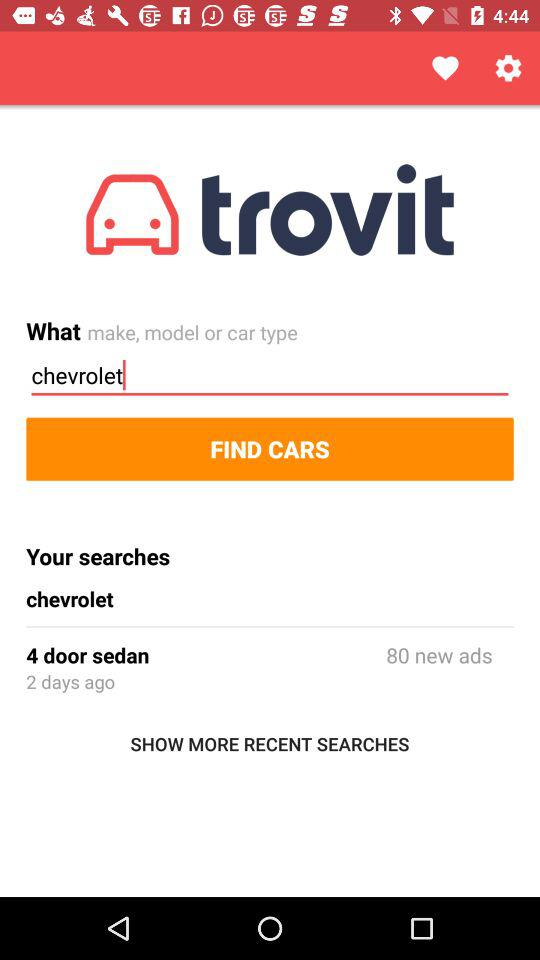What is the car type? The car type is Chevrolet. 